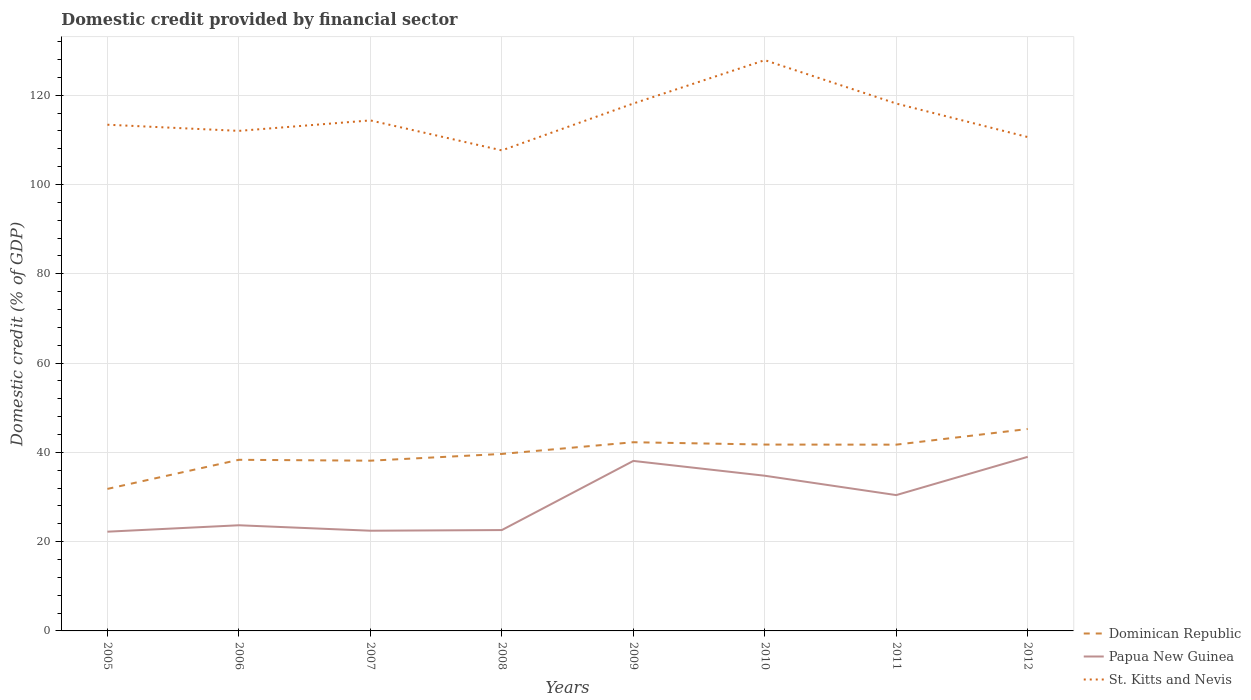How many different coloured lines are there?
Give a very brief answer. 3. Does the line corresponding to Dominican Republic intersect with the line corresponding to Papua New Guinea?
Your response must be concise. No. Across all years, what is the maximum domestic credit in St. Kitts and Nevis?
Provide a succinct answer. 107.64. What is the total domestic credit in St. Kitts and Nevis in the graph?
Keep it short and to the point. 1.39. What is the difference between the highest and the second highest domestic credit in St. Kitts and Nevis?
Your response must be concise. 20.21. What is the difference between the highest and the lowest domestic credit in Papua New Guinea?
Your answer should be very brief. 4. Is the domestic credit in St. Kitts and Nevis strictly greater than the domestic credit in Dominican Republic over the years?
Keep it short and to the point. No. What is the difference between two consecutive major ticks on the Y-axis?
Offer a terse response. 20. Are the values on the major ticks of Y-axis written in scientific E-notation?
Offer a terse response. No. Does the graph contain any zero values?
Give a very brief answer. No. Does the graph contain grids?
Provide a short and direct response. Yes. Where does the legend appear in the graph?
Give a very brief answer. Bottom right. What is the title of the graph?
Offer a terse response. Domestic credit provided by financial sector. What is the label or title of the Y-axis?
Give a very brief answer. Domestic credit (% of GDP). What is the Domestic credit (% of GDP) in Dominican Republic in 2005?
Your response must be concise. 31.81. What is the Domestic credit (% of GDP) of Papua New Guinea in 2005?
Ensure brevity in your answer.  22.23. What is the Domestic credit (% of GDP) of St. Kitts and Nevis in 2005?
Offer a very short reply. 113.39. What is the Domestic credit (% of GDP) of Dominican Republic in 2006?
Provide a succinct answer. 38.33. What is the Domestic credit (% of GDP) of Papua New Guinea in 2006?
Give a very brief answer. 23.67. What is the Domestic credit (% of GDP) in St. Kitts and Nevis in 2006?
Make the answer very short. 112.01. What is the Domestic credit (% of GDP) of Dominican Republic in 2007?
Make the answer very short. 38.13. What is the Domestic credit (% of GDP) in Papua New Guinea in 2007?
Make the answer very short. 22.45. What is the Domestic credit (% of GDP) in St. Kitts and Nevis in 2007?
Your answer should be very brief. 114.36. What is the Domestic credit (% of GDP) of Dominican Republic in 2008?
Offer a very short reply. 39.64. What is the Domestic credit (% of GDP) of Papua New Guinea in 2008?
Offer a very short reply. 22.59. What is the Domestic credit (% of GDP) in St. Kitts and Nevis in 2008?
Keep it short and to the point. 107.64. What is the Domestic credit (% of GDP) of Dominican Republic in 2009?
Provide a succinct answer. 42.27. What is the Domestic credit (% of GDP) in Papua New Guinea in 2009?
Your answer should be compact. 38.08. What is the Domestic credit (% of GDP) of St. Kitts and Nevis in 2009?
Ensure brevity in your answer.  118.14. What is the Domestic credit (% of GDP) of Dominican Republic in 2010?
Ensure brevity in your answer.  41.74. What is the Domestic credit (% of GDP) of Papua New Guinea in 2010?
Your answer should be compact. 34.76. What is the Domestic credit (% of GDP) in St. Kitts and Nevis in 2010?
Your answer should be very brief. 127.85. What is the Domestic credit (% of GDP) in Dominican Republic in 2011?
Your response must be concise. 41.72. What is the Domestic credit (% of GDP) of Papua New Guinea in 2011?
Make the answer very short. 30.43. What is the Domestic credit (% of GDP) of St. Kitts and Nevis in 2011?
Keep it short and to the point. 118.13. What is the Domestic credit (% of GDP) of Dominican Republic in 2012?
Offer a terse response. 45.23. What is the Domestic credit (% of GDP) in Papua New Guinea in 2012?
Provide a short and direct response. 38.99. What is the Domestic credit (% of GDP) of St. Kitts and Nevis in 2012?
Ensure brevity in your answer.  110.62. Across all years, what is the maximum Domestic credit (% of GDP) of Dominican Republic?
Offer a terse response. 45.23. Across all years, what is the maximum Domestic credit (% of GDP) of Papua New Guinea?
Offer a terse response. 38.99. Across all years, what is the maximum Domestic credit (% of GDP) in St. Kitts and Nevis?
Provide a short and direct response. 127.85. Across all years, what is the minimum Domestic credit (% of GDP) of Dominican Republic?
Keep it short and to the point. 31.81. Across all years, what is the minimum Domestic credit (% of GDP) in Papua New Guinea?
Make the answer very short. 22.23. Across all years, what is the minimum Domestic credit (% of GDP) in St. Kitts and Nevis?
Offer a very short reply. 107.64. What is the total Domestic credit (% of GDP) in Dominican Republic in the graph?
Offer a terse response. 318.89. What is the total Domestic credit (% of GDP) in Papua New Guinea in the graph?
Provide a succinct answer. 233.19. What is the total Domestic credit (% of GDP) in St. Kitts and Nevis in the graph?
Ensure brevity in your answer.  922.14. What is the difference between the Domestic credit (% of GDP) in Dominican Republic in 2005 and that in 2006?
Your answer should be very brief. -6.52. What is the difference between the Domestic credit (% of GDP) in Papua New Guinea in 2005 and that in 2006?
Keep it short and to the point. -1.44. What is the difference between the Domestic credit (% of GDP) of St. Kitts and Nevis in 2005 and that in 2006?
Your response must be concise. 1.38. What is the difference between the Domestic credit (% of GDP) of Dominican Republic in 2005 and that in 2007?
Make the answer very short. -6.32. What is the difference between the Domestic credit (% of GDP) in Papua New Guinea in 2005 and that in 2007?
Ensure brevity in your answer.  -0.22. What is the difference between the Domestic credit (% of GDP) in St. Kitts and Nevis in 2005 and that in 2007?
Give a very brief answer. -0.96. What is the difference between the Domestic credit (% of GDP) of Dominican Republic in 2005 and that in 2008?
Keep it short and to the point. -7.83. What is the difference between the Domestic credit (% of GDP) of Papua New Guinea in 2005 and that in 2008?
Make the answer very short. -0.36. What is the difference between the Domestic credit (% of GDP) in St. Kitts and Nevis in 2005 and that in 2008?
Keep it short and to the point. 5.75. What is the difference between the Domestic credit (% of GDP) in Dominican Republic in 2005 and that in 2009?
Ensure brevity in your answer.  -10.45. What is the difference between the Domestic credit (% of GDP) of Papua New Guinea in 2005 and that in 2009?
Provide a short and direct response. -15.85. What is the difference between the Domestic credit (% of GDP) of St. Kitts and Nevis in 2005 and that in 2009?
Your answer should be very brief. -4.75. What is the difference between the Domestic credit (% of GDP) of Dominican Republic in 2005 and that in 2010?
Provide a short and direct response. -9.93. What is the difference between the Domestic credit (% of GDP) in Papua New Guinea in 2005 and that in 2010?
Keep it short and to the point. -12.53. What is the difference between the Domestic credit (% of GDP) in St. Kitts and Nevis in 2005 and that in 2010?
Provide a succinct answer. -14.46. What is the difference between the Domestic credit (% of GDP) of Dominican Republic in 2005 and that in 2011?
Offer a very short reply. -9.91. What is the difference between the Domestic credit (% of GDP) of Papua New Guinea in 2005 and that in 2011?
Offer a very short reply. -8.2. What is the difference between the Domestic credit (% of GDP) of St. Kitts and Nevis in 2005 and that in 2011?
Provide a short and direct response. -4.74. What is the difference between the Domestic credit (% of GDP) of Dominican Republic in 2005 and that in 2012?
Provide a short and direct response. -13.42. What is the difference between the Domestic credit (% of GDP) of Papua New Guinea in 2005 and that in 2012?
Your answer should be very brief. -16.77. What is the difference between the Domestic credit (% of GDP) in St. Kitts and Nevis in 2005 and that in 2012?
Keep it short and to the point. 2.77. What is the difference between the Domestic credit (% of GDP) of Dominican Republic in 2006 and that in 2007?
Make the answer very short. 0.2. What is the difference between the Domestic credit (% of GDP) of Papua New Guinea in 2006 and that in 2007?
Your answer should be very brief. 1.22. What is the difference between the Domestic credit (% of GDP) in St. Kitts and Nevis in 2006 and that in 2007?
Your answer should be very brief. -2.34. What is the difference between the Domestic credit (% of GDP) of Dominican Republic in 2006 and that in 2008?
Give a very brief answer. -1.31. What is the difference between the Domestic credit (% of GDP) of Papua New Guinea in 2006 and that in 2008?
Provide a succinct answer. 1.07. What is the difference between the Domestic credit (% of GDP) in St. Kitts and Nevis in 2006 and that in 2008?
Offer a very short reply. 4.37. What is the difference between the Domestic credit (% of GDP) in Dominican Republic in 2006 and that in 2009?
Your answer should be compact. -3.93. What is the difference between the Domestic credit (% of GDP) of Papua New Guinea in 2006 and that in 2009?
Provide a succinct answer. -14.41. What is the difference between the Domestic credit (% of GDP) in St. Kitts and Nevis in 2006 and that in 2009?
Give a very brief answer. -6.13. What is the difference between the Domestic credit (% of GDP) in Dominican Republic in 2006 and that in 2010?
Provide a succinct answer. -3.41. What is the difference between the Domestic credit (% of GDP) of Papua New Guinea in 2006 and that in 2010?
Your answer should be compact. -11.1. What is the difference between the Domestic credit (% of GDP) in St. Kitts and Nevis in 2006 and that in 2010?
Ensure brevity in your answer.  -15.84. What is the difference between the Domestic credit (% of GDP) in Dominican Republic in 2006 and that in 2011?
Your answer should be very brief. -3.39. What is the difference between the Domestic credit (% of GDP) in Papua New Guinea in 2006 and that in 2011?
Give a very brief answer. -6.76. What is the difference between the Domestic credit (% of GDP) in St. Kitts and Nevis in 2006 and that in 2011?
Keep it short and to the point. -6.12. What is the difference between the Domestic credit (% of GDP) of Dominican Republic in 2006 and that in 2012?
Your response must be concise. -6.9. What is the difference between the Domestic credit (% of GDP) in Papua New Guinea in 2006 and that in 2012?
Your answer should be compact. -15.33. What is the difference between the Domestic credit (% of GDP) in St. Kitts and Nevis in 2006 and that in 2012?
Provide a succinct answer. 1.39. What is the difference between the Domestic credit (% of GDP) in Dominican Republic in 2007 and that in 2008?
Make the answer very short. -1.51. What is the difference between the Domestic credit (% of GDP) of Papua New Guinea in 2007 and that in 2008?
Ensure brevity in your answer.  -0.15. What is the difference between the Domestic credit (% of GDP) in St. Kitts and Nevis in 2007 and that in 2008?
Offer a terse response. 6.72. What is the difference between the Domestic credit (% of GDP) in Dominican Republic in 2007 and that in 2009?
Your answer should be very brief. -4.13. What is the difference between the Domestic credit (% of GDP) of Papua New Guinea in 2007 and that in 2009?
Keep it short and to the point. -15.63. What is the difference between the Domestic credit (% of GDP) in St. Kitts and Nevis in 2007 and that in 2009?
Your response must be concise. -3.78. What is the difference between the Domestic credit (% of GDP) of Dominican Republic in 2007 and that in 2010?
Ensure brevity in your answer.  -3.61. What is the difference between the Domestic credit (% of GDP) of Papua New Guinea in 2007 and that in 2010?
Your response must be concise. -12.32. What is the difference between the Domestic credit (% of GDP) in St. Kitts and Nevis in 2007 and that in 2010?
Offer a very short reply. -13.5. What is the difference between the Domestic credit (% of GDP) in Dominican Republic in 2007 and that in 2011?
Make the answer very short. -3.59. What is the difference between the Domestic credit (% of GDP) in Papua New Guinea in 2007 and that in 2011?
Offer a terse response. -7.98. What is the difference between the Domestic credit (% of GDP) in St. Kitts and Nevis in 2007 and that in 2011?
Offer a very short reply. -3.78. What is the difference between the Domestic credit (% of GDP) of Dominican Republic in 2007 and that in 2012?
Give a very brief answer. -7.1. What is the difference between the Domestic credit (% of GDP) of Papua New Guinea in 2007 and that in 2012?
Keep it short and to the point. -16.55. What is the difference between the Domestic credit (% of GDP) of St. Kitts and Nevis in 2007 and that in 2012?
Ensure brevity in your answer.  3.73. What is the difference between the Domestic credit (% of GDP) in Dominican Republic in 2008 and that in 2009?
Give a very brief answer. -2.62. What is the difference between the Domestic credit (% of GDP) in Papua New Guinea in 2008 and that in 2009?
Your answer should be compact. -15.49. What is the difference between the Domestic credit (% of GDP) in St. Kitts and Nevis in 2008 and that in 2009?
Make the answer very short. -10.5. What is the difference between the Domestic credit (% of GDP) in Dominican Republic in 2008 and that in 2010?
Your response must be concise. -2.1. What is the difference between the Domestic credit (% of GDP) in Papua New Guinea in 2008 and that in 2010?
Offer a very short reply. -12.17. What is the difference between the Domestic credit (% of GDP) in St. Kitts and Nevis in 2008 and that in 2010?
Your answer should be compact. -20.21. What is the difference between the Domestic credit (% of GDP) of Dominican Republic in 2008 and that in 2011?
Make the answer very short. -2.08. What is the difference between the Domestic credit (% of GDP) of Papua New Guinea in 2008 and that in 2011?
Provide a short and direct response. -7.83. What is the difference between the Domestic credit (% of GDP) of St. Kitts and Nevis in 2008 and that in 2011?
Provide a succinct answer. -10.5. What is the difference between the Domestic credit (% of GDP) of Dominican Republic in 2008 and that in 2012?
Make the answer very short. -5.59. What is the difference between the Domestic credit (% of GDP) in Papua New Guinea in 2008 and that in 2012?
Make the answer very short. -16.4. What is the difference between the Domestic credit (% of GDP) in St. Kitts and Nevis in 2008 and that in 2012?
Offer a very short reply. -2.99. What is the difference between the Domestic credit (% of GDP) of Dominican Republic in 2009 and that in 2010?
Your response must be concise. 0.52. What is the difference between the Domestic credit (% of GDP) of Papua New Guinea in 2009 and that in 2010?
Offer a terse response. 3.31. What is the difference between the Domestic credit (% of GDP) in St. Kitts and Nevis in 2009 and that in 2010?
Keep it short and to the point. -9.72. What is the difference between the Domestic credit (% of GDP) in Dominican Republic in 2009 and that in 2011?
Keep it short and to the point. 0.54. What is the difference between the Domestic credit (% of GDP) in Papua New Guinea in 2009 and that in 2011?
Offer a terse response. 7.65. What is the difference between the Domestic credit (% of GDP) in St. Kitts and Nevis in 2009 and that in 2011?
Your answer should be very brief. 0. What is the difference between the Domestic credit (% of GDP) of Dominican Republic in 2009 and that in 2012?
Your answer should be very brief. -2.97. What is the difference between the Domestic credit (% of GDP) in Papua New Guinea in 2009 and that in 2012?
Your answer should be very brief. -0.92. What is the difference between the Domestic credit (% of GDP) in St. Kitts and Nevis in 2009 and that in 2012?
Provide a short and direct response. 7.51. What is the difference between the Domestic credit (% of GDP) in Papua New Guinea in 2010 and that in 2011?
Your answer should be compact. 4.34. What is the difference between the Domestic credit (% of GDP) of St. Kitts and Nevis in 2010 and that in 2011?
Provide a short and direct response. 9.72. What is the difference between the Domestic credit (% of GDP) in Dominican Republic in 2010 and that in 2012?
Your response must be concise. -3.49. What is the difference between the Domestic credit (% of GDP) of Papua New Guinea in 2010 and that in 2012?
Offer a very short reply. -4.23. What is the difference between the Domestic credit (% of GDP) in St. Kitts and Nevis in 2010 and that in 2012?
Offer a terse response. 17.23. What is the difference between the Domestic credit (% of GDP) in Dominican Republic in 2011 and that in 2012?
Ensure brevity in your answer.  -3.51. What is the difference between the Domestic credit (% of GDP) in Papua New Guinea in 2011 and that in 2012?
Offer a terse response. -8.57. What is the difference between the Domestic credit (% of GDP) of St. Kitts and Nevis in 2011 and that in 2012?
Provide a short and direct response. 7.51. What is the difference between the Domestic credit (% of GDP) in Dominican Republic in 2005 and the Domestic credit (% of GDP) in Papua New Guinea in 2006?
Make the answer very short. 8.15. What is the difference between the Domestic credit (% of GDP) of Dominican Republic in 2005 and the Domestic credit (% of GDP) of St. Kitts and Nevis in 2006?
Your response must be concise. -80.2. What is the difference between the Domestic credit (% of GDP) in Papua New Guinea in 2005 and the Domestic credit (% of GDP) in St. Kitts and Nevis in 2006?
Provide a short and direct response. -89.78. What is the difference between the Domestic credit (% of GDP) in Dominican Republic in 2005 and the Domestic credit (% of GDP) in Papua New Guinea in 2007?
Make the answer very short. 9.37. What is the difference between the Domestic credit (% of GDP) of Dominican Republic in 2005 and the Domestic credit (% of GDP) of St. Kitts and Nevis in 2007?
Your answer should be very brief. -82.54. What is the difference between the Domestic credit (% of GDP) of Papua New Guinea in 2005 and the Domestic credit (% of GDP) of St. Kitts and Nevis in 2007?
Provide a short and direct response. -92.13. What is the difference between the Domestic credit (% of GDP) of Dominican Republic in 2005 and the Domestic credit (% of GDP) of Papua New Guinea in 2008?
Give a very brief answer. 9.22. What is the difference between the Domestic credit (% of GDP) in Dominican Republic in 2005 and the Domestic credit (% of GDP) in St. Kitts and Nevis in 2008?
Keep it short and to the point. -75.82. What is the difference between the Domestic credit (% of GDP) in Papua New Guinea in 2005 and the Domestic credit (% of GDP) in St. Kitts and Nevis in 2008?
Offer a terse response. -85.41. What is the difference between the Domestic credit (% of GDP) in Dominican Republic in 2005 and the Domestic credit (% of GDP) in Papua New Guinea in 2009?
Keep it short and to the point. -6.26. What is the difference between the Domestic credit (% of GDP) in Dominican Republic in 2005 and the Domestic credit (% of GDP) in St. Kitts and Nevis in 2009?
Offer a terse response. -86.32. What is the difference between the Domestic credit (% of GDP) in Papua New Guinea in 2005 and the Domestic credit (% of GDP) in St. Kitts and Nevis in 2009?
Give a very brief answer. -95.91. What is the difference between the Domestic credit (% of GDP) of Dominican Republic in 2005 and the Domestic credit (% of GDP) of Papua New Guinea in 2010?
Keep it short and to the point. -2.95. What is the difference between the Domestic credit (% of GDP) of Dominican Republic in 2005 and the Domestic credit (% of GDP) of St. Kitts and Nevis in 2010?
Your response must be concise. -96.04. What is the difference between the Domestic credit (% of GDP) of Papua New Guinea in 2005 and the Domestic credit (% of GDP) of St. Kitts and Nevis in 2010?
Make the answer very short. -105.62. What is the difference between the Domestic credit (% of GDP) in Dominican Republic in 2005 and the Domestic credit (% of GDP) in Papua New Guinea in 2011?
Offer a terse response. 1.39. What is the difference between the Domestic credit (% of GDP) of Dominican Republic in 2005 and the Domestic credit (% of GDP) of St. Kitts and Nevis in 2011?
Offer a terse response. -86.32. What is the difference between the Domestic credit (% of GDP) in Papua New Guinea in 2005 and the Domestic credit (% of GDP) in St. Kitts and Nevis in 2011?
Provide a succinct answer. -95.91. What is the difference between the Domestic credit (% of GDP) of Dominican Republic in 2005 and the Domestic credit (% of GDP) of Papua New Guinea in 2012?
Your answer should be very brief. -7.18. What is the difference between the Domestic credit (% of GDP) of Dominican Republic in 2005 and the Domestic credit (% of GDP) of St. Kitts and Nevis in 2012?
Your answer should be compact. -78.81. What is the difference between the Domestic credit (% of GDP) in Papua New Guinea in 2005 and the Domestic credit (% of GDP) in St. Kitts and Nevis in 2012?
Your response must be concise. -88.4. What is the difference between the Domestic credit (% of GDP) in Dominican Republic in 2006 and the Domestic credit (% of GDP) in Papua New Guinea in 2007?
Your answer should be very brief. 15.89. What is the difference between the Domestic credit (% of GDP) of Dominican Republic in 2006 and the Domestic credit (% of GDP) of St. Kitts and Nevis in 2007?
Offer a terse response. -76.02. What is the difference between the Domestic credit (% of GDP) of Papua New Guinea in 2006 and the Domestic credit (% of GDP) of St. Kitts and Nevis in 2007?
Keep it short and to the point. -90.69. What is the difference between the Domestic credit (% of GDP) in Dominican Republic in 2006 and the Domestic credit (% of GDP) in Papua New Guinea in 2008?
Keep it short and to the point. 15.74. What is the difference between the Domestic credit (% of GDP) in Dominican Republic in 2006 and the Domestic credit (% of GDP) in St. Kitts and Nevis in 2008?
Keep it short and to the point. -69.31. What is the difference between the Domestic credit (% of GDP) in Papua New Guinea in 2006 and the Domestic credit (% of GDP) in St. Kitts and Nevis in 2008?
Your response must be concise. -83.97. What is the difference between the Domestic credit (% of GDP) in Dominican Republic in 2006 and the Domestic credit (% of GDP) in Papua New Guinea in 2009?
Provide a short and direct response. 0.25. What is the difference between the Domestic credit (% of GDP) of Dominican Republic in 2006 and the Domestic credit (% of GDP) of St. Kitts and Nevis in 2009?
Ensure brevity in your answer.  -79.8. What is the difference between the Domestic credit (% of GDP) in Papua New Guinea in 2006 and the Domestic credit (% of GDP) in St. Kitts and Nevis in 2009?
Make the answer very short. -94.47. What is the difference between the Domestic credit (% of GDP) of Dominican Republic in 2006 and the Domestic credit (% of GDP) of Papua New Guinea in 2010?
Provide a short and direct response. 3.57. What is the difference between the Domestic credit (% of GDP) in Dominican Republic in 2006 and the Domestic credit (% of GDP) in St. Kitts and Nevis in 2010?
Ensure brevity in your answer.  -89.52. What is the difference between the Domestic credit (% of GDP) in Papua New Guinea in 2006 and the Domestic credit (% of GDP) in St. Kitts and Nevis in 2010?
Keep it short and to the point. -104.19. What is the difference between the Domestic credit (% of GDP) of Dominican Republic in 2006 and the Domestic credit (% of GDP) of Papua New Guinea in 2011?
Offer a very short reply. 7.91. What is the difference between the Domestic credit (% of GDP) of Dominican Republic in 2006 and the Domestic credit (% of GDP) of St. Kitts and Nevis in 2011?
Make the answer very short. -79.8. What is the difference between the Domestic credit (% of GDP) in Papua New Guinea in 2006 and the Domestic credit (% of GDP) in St. Kitts and Nevis in 2011?
Your answer should be compact. -94.47. What is the difference between the Domestic credit (% of GDP) of Dominican Republic in 2006 and the Domestic credit (% of GDP) of Papua New Guinea in 2012?
Give a very brief answer. -0.66. What is the difference between the Domestic credit (% of GDP) of Dominican Republic in 2006 and the Domestic credit (% of GDP) of St. Kitts and Nevis in 2012?
Provide a succinct answer. -72.29. What is the difference between the Domestic credit (% of GDP) in Papua New Guinea in 2006 and the Domestic credit (% of GDP) in St. Kitts and Nevis in 2012?
Your response must be concise. -86.96. What is the difference between the Domestic credit (% of GDP) of Dominican Republic in 2007 and the Domestic credit (% of GDP) of Papua New Guinea in 2008?
Your answer should be compact. 15.54. What is the difference between the Domestic credit (% of GDP) of Dominican Republic in 2007 and the Domestic credit (% of GDP) of St. Kitts and Nevis in 2008?
Provide a succinct answer. -69.51. What is the difference between the Domestic credit (% of GDP) in Papua New Guinea in 2007 and the Domestic credit (% of GDP) in St. Kitts and Nevis in 2008?
Keep it short and to the point. -85.19. What is the difference between the Domestic credit (% of GDP) of Dominican Republic in 2007 and the Domestic credit (% of GDP) of Papua New Guinea in 2009?
Make the answer very short. 0.06. What is the difference between the Domestic credit (% of GDP) of Dominican Republic in 2007 and the Domestic credit (% of GDP) of St. Kitts and Nevis in 2009?
Your response must be concise. -80. What is the difference between the Domestic credit (% of GDP) in Papua New Guinea in 2007 and the Domestic credit (% of GDP) in St. Kitts and Nevis in 2009?
Give a very brief answer. -95.69. What is the difference between the Domestic credit (% of GDP) of Dominican Republic in 2007 and the Domestic credit (% of GDP) of Papua New Guinea in 2010?
Give a very brief answer. 3.37. What is the difference between the Domestic credit (% of GDP) in Dominican Republic in 2007 and the Domestic credit (% of GDP) in St. Kitts and Nevis in 2010?
Offer a terse response. -89.72. What is the difference between the Domestic credit (% of GDP) in Papua New Guinea in 2007 and the Domestic credit (% of GDP) in St. Kitts and Nevis in 2010?
Keep it short and to the point. -105.41. What is the difference between the Domestic credit (% of GDP) in Dominican Republic in 2007 and the Domestic credit (% of GDP) in Papua New Guinea in 2011?
Your response must be concise. 7.71. What is the difference between the Domestic credit (% of GDP) of Dominican Republic in 2007 and the Domestic credit (% of GDP) of St. Kitts and Nevis in 2011?
Your answer should be compact. -80. What is the difference between the Domestic credit (% of GDP) in Papua New Guinea in 2007 and the Domestic credit (% of GDP) in St. Kitts and Nevis in 2011?
Give a very brief answer. -95.69. What is the difference between the Domestic credit (% of GDP) in Dominican Republic in 2007 and the Domestic credit (% of GDP) in Papua New Guinea in 2012?
Your response must be concise. -0.86. What is the difference between the Domestic credit (% of GDP) of Dominican Republic in 2007 and the Domestic credit (% of GDP) of St. Kitts and Nevis in 2012?
Provide a succinct answer. -72.49. What is the difference between the Domestic credit (% of GDP) in Papua New Guinea in 2007 and the Domestic credit (% of GDP) in St. Kitts and Nevis in 2012?
Keep it short and to the point. -88.18. What is the difference between the Domestic credit (% of GDP) in Dominican Republic in 2008 and the Domestic credit (% of GDP) in Papua New Guinea in 2009?
Keep it short and to the point. 1.57. What is the difference between the Domestic credit (% of GDP) of Dominican Republic in 2008 and the Domestic credit (% of GDP) of St. Kitts and Nevis in 2009?
Your answer should be compact. -78.49. What is the difference between the Domestic credit (% of GDP) of Papua New Guinea in 2008 and the Domestic credit (% of GDP) of St. Kitts and Nevis in 2009?
Make the answer very short. -95.54. What is the difference between the Domestic credit (% of GDP) in Dominican Republic in 2008 and the Domestic credit (% of GDP) in Papua New Guinea in 2010?
Provide a short and direct response. 4.88. What is the difference between the Domestic credit (% of GDP) in Dominican Republic in 2008 and the Domestic credit (% of GDP) in St. Kitts and Nevis in 2010?
Make the answer very short. -88.21. What is the difference between the Domestic credit (% of GDP) of Papua New Guinea in 2008 and the Domestic credit (% of GDP) of St. Kitts and Nevis in 2010?
Your response must be concise. -105.26. What is the difference between the Domestic credit (% of GDP) in Dominican Republic in 2008 and the Domestic credit (% of GDP) in Papua New Guinea in 2011?
Provide a short and direct response. 9.22. What is the difference between the Domestic credit (% of GDP) in Dominican Republic in 2008 and the Domestic credit (% of GDP) in St. Kitts and Nevis in 2011?
Ensure brevity in your answer.  -78.49. What is the difference between the Domestic credit (% of GDP) of Papua New Guinea in 2008 and the Domestic credit (% of GDP) of St. Kitts and Nevis in 2011?
Offer a terse response. -95.54. What is the difference between the Domestic credit (% of GDP) in Dominican Republic in 2008 and the Domestic credit (% of GDP) in Papua New Guinea in 2012?
Your answer should be very brief. 0.65. What is the difference between the Domestic credit (% of GDP) in Dominican Republic in 2008 and the Domestic credit (% of GDP) in St. Kitts and Nevis in 2012?
Provide a short and direct response. -70.98. What is the difference between the Domestic credit (% of GDP) of Papua New Guinea in 2008 and the Domestic credit (% of GDP) of St. Kitts and Nevis in 2012?
Your answer should be very brief. -88.03. What is the difference between the Domestic credit (% of GDP) of Dominican Republic in 2009 and the Domestic credit (% of GDP) of Papua New Guinea in 2010?
Ensure brevity in your answer.  7.5. What is the difference between the Domestic credit (% of GDP) of Dominican Republic in 2009 and the Domestic credit (% of GDP) of St. Kitts and Nevis in 2010?
Your answer should be compact. -85.59. What is the difference between the Domestic credit (% of GDP) of Papua New Guinea in 2009 and the Domestic credit (% of GDP) of St. Kitts and Nevis in 2010?
Provide a succinct answer. -89.78. What is the difference between the Domestic credit (% of GDP) of Dominican Republic in 2009 and the Domestic credit (% of GDP) of Papua New Guinea in 2011?
Offer a very short reply. 11.84. What is the difference between the Domestic credit (% of GDP) of Dominican Republic in 2009 and the Domestic credit (% of GDP) of St. Kitts and Nevis in 2011?
Give a very brief answer. -75.87. What is the difference between the Domestic credit (% of GDP) in Papua New Guinea in 2009 and the Domestic credit (% of GDP) in St. Kitts and Nevis in 2011?
Your answer should be compact. -80.06. What is the difference between the Domestic credit (% of GDP) of Dominican Republic in 2009 and the Domestic credit (% of GDP) of Papua New Guinea in 2012?
Offer a very short reply. 3.27. What is the difference between the Domestic credit (% of GDP) of Dominican Republic in 2009 and the Domestic credit (% of GDP) of St. Kitts and Nevis in 2012?
Offer a very short reply. -68.36. What is the difference between the Domestic credit (% of GDP) of Papua New Guinea in 2009 and the Domestic credit (% of GDP) of St. Kitts and Nevis in 2012?
Your answer should be compact. -72.55. What is the difference between the Domestic credit (% of GDP) in Dominican Republic in 2010 and the Domestic credit (% of GDP) in Papua New Guinea in 2011?
Offer a terse response. 11.32. What is the difference between the Domestic credit (% of GDP) of Dominican Republic in 2010 and the Domestic credit (% of GDP) of St. Kitts and Nevis in 2011?
Offer a very short reply. -76.39. What is the difference between the Domestic credit (% of GDP) in Papua New Guinea in 2010 and the Domestic credit (% of GDP) in St. Kitts and Nevis in 2011?
Make the answer very short. -83.37. What is the difference between the Domestic credit (% of GDP) in Dominican Republic in 2010 and the Domestic credit (% of GDP) in Papua New Guinea in 2012?
Your response must be concise. 2.75. What is the difference between the Domestic credit (% of GDP) in Dominican Republic in 2010 and the Domestic credit (% of GDP) in St. Kitts and Nevis in 2012?
Keep it short and to the point. -68.88. What is the difference between the Domestic credit (% of GDP) of Papua New Guinea in 2010 and the Domestic credit (% of GDP) of St. Kitts and Nevis in 2012?
Your answer should be very brief. -75.86. What is the difference between the Domestic credit (% of GDP) in Dominican Republic in 2011 and the Domestic credit (% of GDP) in Papua New Guinea in 2012?
Give a very brief answer. 2.73. What is the difference between the Domestic credit (% of GDP) of Dominican Republic in 2011 and the Domestic credit (% of GDP) of St. Kitts and Nevis in 2012?
Ensure brevity in your answer.  -68.9. What is the difference between the Domestic credit (% of GDP) of Papua New Guinea in 2011 and the Domestic credit (% of GDP) of St. Kitts and Nevis in 2012?
Give a very brief answer. -80.2. What is the average Domestic credit (% of GDP) of Dominican Republic per year?
Ensure brevity in your answer.  39.86. What is the average Domestic credit (% of GDP) in Papua New Guinea per year?
Provide a succinct answer. 29.15. What is the average Domestic credit (% of GDP) of St. Kitts and Nevis per year?
Provide a short and direct response. 115.27. In the year 2005, what is the difference between the Domestic credit (% of GDP) in Dominican Republic and Domestic credit (% of GDP) in Papua New Guinea?
Ensure brevity in your answer.  9.59. In the year 2005, what is the difference between the Domestic credit (% of GDP) in Dominican Republic and Domestic credit (% of GDP) in St. Kitts and Nevis?
Make the answer very short. -81.58. In the year 2005, what is the difference between the Domestic credit (% of GDP) in Papua New Guinea and Domestic credit (% of GDP) in St. Kitts and Nevis?
Offer a terse response. -91.16. In the year 2006, what is the difference between the Domestic credit (% of GDP) of Dominican Republic and Domestic credit (% of GDP) of Papua New Guinea?
Your answer should be compact. 14.67. In the year 2006, what is the difference between the Domestic credit (% of GDP) of Dominican Republic and Domestic credit (% of GDP) of St. Kitts and Nevis?
Make the answer very short. -73.68. In the year 2006, what is the difference between the Domestic credit (% of GDP) of Papua New Guinea and Domestic credit (% of GDP) of St. Kitts and Nevis?
Your answer should be compact. -88.34. In the year 2007, what is the difference between the Domestic credit (% of GDP) of Dominican Republic and Domestic credit (% of GDP) of Papua New Guinea?
Offer a very short reply. 15.69. In the year 2007, what is the difference between the Domestic credit (% of GDP) of Dominican Republic and Domestic credit (% of GDP) of St. Kitts and Nevis?
Your answer should be compact. -76.22. In the year 2007, what is the difference between the Domestic credit (% of GDP) in Papua New Guinea and Domestic credit (% of GDP) in St. Kitts and Nevis?
Your answer should be compact. -91.91. In the year 2008, what is the difference between the Domestic credit (% of GDP) of Dominican Republic and Domestic credit (% of GDP) of Papua New Guinea?
Keep it short and to the point. 17.05. In the year 2008, what is the difference between the Domestic credit (% of GDP) of Dominican Republic and Domestic credit (% of GDP) of St. Kitts and Nevis?
Keep it short and to the point. -67.99. In the year 2008, what is the difference between the Domestic credit (% of GDP) of Papua New Guinea and Domestic credit (% of GDP) of St. Kitts and Nevis?
Ensure brevity in your answer.  -85.05. In the year 2009, what is the difference between the Domestic credit (% of GDP) of Dominican Republic and Domestic credit (% of GDP) of Papua New Guinea?
Offer a very short reply. 4.19. In the year 2009, what is the difference between the Domestic credit (% of GDP) in Dominican Republic and Domestic credit (% of GDP) in St. Kitts and Nevis?
Make the answer very short. -75.87. In the year 2009, what is the difference between the Domestic credit (% of GDP) of Papua New Guinea and Domestic credit (% of GDP) of St. Kitts and Nevis?
Your response must be concise. -80.06. In the year 2010, what is the difference between the Domestic credit (% of GDP) in Dominican Republic and Domestic credit (% of GDP) in Papua New Guinea?
Provide a succinct answer. 6.98. In the year 2010, what is the difference between the Domestic credit (% of GDP) of Dominican Republic and Domestic credit (% of GDP) of St. Kitts and Nevis?
Keep it short and to the point. -86.11. In the year 2010, what is the difference between the Domestic credit (% of GDP) in Papua New Guinea and Domestic credit (% of GDP) in St. Kitts and Nevis?
Offer a terse response. -93.09. In the year 2011, what is the difference between the Domestic credit (% of GDP) in Dominican Republic and Domestic credit (% of GDP) in Papua New Guinea?
Your answer should be compact. 11.3. In the year 2011, what is the difference between the Domestic credit (% of GDP) of Dominican Republic and Domestic credit (% of GDP) of St. Kitts and Nevis?
Offer a very short reply. -76.41. In the year 2011, what is the difference between the Domestic credit (% of GDP) in Papua New Guinea and Domestic credit (% of GDP) in St. Kitts and Nevis?
Your answer should be compact. -87.71. In the year 2012, what is the difference between the Domestic credit (% of GDP) of Dominican Republic and Domestic credit (% of GDP) of Papua New Guinea?
Provide a succinct answer. 6.24. In the year 2012, what is the difference between the Domestic credit (% of GDP) of Dominican Republic and Domestic credit (% of GDP) of St. Kitts and Nevis?
Your response must be concise. -65.39. In the year 2012, what is the difference between the Domestic credit (% of GDP) of Papua New Guinea and Domestic credit (% of GDP) of St. Kitts and Nevis?
Give a very brief answer. -71.63. What is the ratio of the Domestic credit (% of GDP) in Dominican Republic in 2005 to that in 2006?
Make the answer very short. 0.83. What is the ratio of the Domestic credit (% of GDP) in Papua New Guinea in 2005 to that in 2006?
Offer a terse response. 0.94. What is the ratio of the Domestic credit (% of GDP) in St. Kitts and Nevis in 2005 to that in 2006?
Provide a succinct answer. 1.01. What is the ratio of the Domestic credit (% of GDP) in Dominican Republic in 2005 to that in 2007?
Provide a succinct answer. 0.83. What is the ratio of the Domestic credit (% of GDP) in Papua New Guinea in 2005 to that in 2007?
Offer a very short reply. 0.99. What is the ratio of the Domestic credit (% of GDP) in St. Kitts and Nevis in 2005 to that in 2007?
Give a very brief answer. 0.99. What is the ratio of the Domestic credit (% of GDP) in Dominican Republic in 2005 to that in 2008?
Your answer should be very brief. 0.8. What is the ratio of the Domestic credit (% of GDP) of Papua New Guinea in 2005 to that in 2008?
Offer a terse response. 0.98. What is the ratio of the Domestic credit (% of GDP) of St. Kitts and Nevis in 2005 to that in 2008?
Give a very brief answer. 1.05. What is the ratio of the Domestic credit (% of GDP) in Dominican Republic in 2005 to that in 2009?
Your answer should be compact. 0.75. What is the ratio of the Domestic credit (% of GDP) of Papua New Guinea in 2005 to that in 2009?
Ensure brevity in your answer.  0.58. What is the ratio of the Domestic credit (% of GDP) in St. Kitts and Nevis in 2005 to that in 2009?
Offer a very short reply. 0.96. What is the ratio of the Domestic credit (% of GDP) of Dominican Republic in 2005 to that in 2010?
Ensure brevity in your answer.  0.76. What is the ratio of the Domestic credit (% of GDP) in Papua New Guinea in 2005 to that in 2010?
Offer a terse response. 0.64. What is the ratio of the Domestic credit (% of GDP) in St. Kitts and Nevis in 2005 to that in 2010?
Make the answer very short. 0.89. What is the ratio of the Domestic credit (% of GDP) of Dominican Republic in 2005 to that in 2011?
Your answer should be compact. 0.76. What is the ratio of the Domestic credit (% of GDP) in Papua New Guinea in 2005 to that in 2011?
Your response must be concise. 0.73. What is the ratio of the Domestic credit (% of GDP) in St. Kitts and Nevis in 2005 to that in 2011?
Provide a short and direct response. 0.96. What is the ratio of the Domestic credit (% of GDP) in Dominican Republic in 2005 to that in 2012?
Keep it short and to the point. 0.7. What is the ratio of the Domestic credit (% of GDP) in Papua New Guinea in 2005 to that in 2012?
Your response must be concise. 0.57. What is the ratio of the Domestic credit (% of GDP) of St. Kitts and Nevis in 2005 to that in 2012?
Make the answer very short. 1.02. What is the ratio of the Domestic credit (% of GDP) of Dominican Republic in 2006 to that in 2007?
Provide a succinct answer. 1.01. What is the ratio of the Domestic credit (% of GDP) in Papua New Guinea in 2006 to that in 2007?
Make the answer very short. 1.05. What is the ratio of the Domestic credit (% of GDP) in St. Kitts and Nevis in 2006 to that in 2007?
Offer a terse response. 0.98. What is the ratio of the Domestic credit (% of GDP) of Dominican Republic in 2006 to that in 2008?
Ensure brevity in your answer.  0.97. What is the ratio of the Domestic credit (% of GDP) of Papua New Guinea in 2006 to that in 2008?
Provide a short and direct response. 1.05. What is the ratio of the Domestic credit (% of GDP) in St. Kitts and Nevis in 2006 to that in 2008?
Offer a terse response. 1.04. What is the ratio of the Domestic credit (% of GDP) of Dominican Republic in 2006 to that in 2009?
Offer a very short reply. 0.91. What is the ratio of the Domestic credit (% of GDP) of Papua New Guinea in 2006 to that in 2009?
Your answer should be compact. 0.62. What is the ratio of the Domestic credit (% of GDP) in St. Kitts and Nevis in 2006 to that in 2009?
Offer a terse response. 0.95. What is the ratio of the Domestic credit (% of GDP) of Dominican Republic in 2006 to that in 2010?
Your answer should be compact. 0.92. What is the ratio of the Domestic credit (% of GDP) of Papua New Guinea in 2006 to that in 2010?
Provide a short and direct response. 0.68. What is the ratio of the Domestic credit (% of GDP) in St. Kitts and Nevis in 2006 to that in 2010?
Offer a very short reply. 0.88. What is the ratio of the Domestic credit (% of GDP) in Dominican Republic in 2006 to that in 2011?
Keep it short and to the point. 0.92. What is the ratio of the Domestic credit (% of GDP) in St. Kitts and Nevis in 2006 to that in 2011?
Make the answer very short. 0.95. What is the ratio of the Domestic credit (% of GDP) in Dominican Republic in 2006 to that in 2012?
Give a very brief answer. 0.85. What is the ratio of the Domestic credit (% of GDP) of Papua New Guinea in 2006 to that in 2012?
Offer a very short reply. 0.61. What is the ratio of the Domestic credit (% of GDP) in St. Kitts and Nevis in 2006 to that in 2012?
Offer a terse response. 1.01. What is the ratio of the Domestic credit (% of GDP) in Dominican Republic in 2007 to that in 2008?
Your answer should be compact. 0.96. What is the ratio of the Domestic credit (% of GDP) of St. Kitts and Nevis in 2007 to that in 2008?
Your answer should be very brief. 1.06. What is the ratio of the Domestic credit (% of GDP) of Dominican Republic in 2007 to that in 2009?
Provide a short and direct response. 0.9. What is the ratio of the Domestic credit (% of GDP) in Papua New Guinea in 2007 to that in 2009?
Your answer should be compact. 0.59. What is the ratio of the Domestic credit (% of GDP) in Dominican Republic in 2007 to that in 2010?
Ensure brevity in your answer.  0.91. What is the ratio of the Domestic credit (% of GDP) of Papua New Guinea in 2007 to that in 2010?
Provide a short and direct response. 0.65. What is the ratio of the Domestic credit (% of GDP) in St. Kitts and Nevis in 2007 to that in 2010?
Keep it short and to the point. 0.89. What is the ratio of the Domestic credit (% of GDP) of Dominican Republic in 2007 to that in 2011?
Offer a very short reply. 0.91. What is the ratio of the Domestic credit (% of GDP) in Papua New Guinea in 2007 to that in 2011?
Offer a terse response. 0.74. What is the ratio of the Domestic credit (% of GDP) in St. Kitts and Nevis in 2007 to that in 2011?
Offer a very short reply. 0.97. What is the ratio of the Domestic credit (% of GDP) of Dominican Republic in 2007 to that in 2012?
Provide a short and direct response. 0.84. What is the ratio of the Domestic credit (% of GDP) of Papua New Guinea in 2007 to that in 2012?
Provide a short and direct response. 0.58. What is the ratio of the Domestic credit (% of GDP) in St. Kitts and Nevis in 2007 to that in 2012?
Keep it short and to the point. 1.03. What is the ratio of the Domestic credit (% of GDP) in Dominican Republic in 2008 to that in 2009?
Your answer should be compact. 0.94. What is the ratio of the Domestic credit (% of GDP) of Papua New Guinea in 2008 to that in 2009?
Your answer should be compact. 0.59. What is the ratio of the Domestic credit (% of GDP) of St. Kitts and Nevis in 2008 to that in 2009?
Offer a very short reply. 0.91. What is the ratio of the Domestic credit (% of GDP) of Dominican Republic in 2008 to that in 2010?
Provide a succinct answer. 0.95. What is the ratio of the Domestic credit (% of GDP) in Papua New Guinea in 2008 to that in 2010?
Offer a very short reply. 0.65. What is the ratio of the Domestic credit (% of GDP) of St. Kitts and Nevis in 2008 to that in 2010?
Offer a terse response. 0.84. What is the ratio of the Domestic credit (% of GDP) of Dominican Republic in 2008 to that in 2011?
Your response must be concise. 0.95. What is the ratio of the Domestic credit (% of GDP) in Papua New Guinea in 2008 to that in 2011?
Your answer should be very brief. 0.74. What is the ratio of the Domestic credit (% of GDP) in St. Kitts and Nevis in 2008 to that in 2011?
Provide a succinct answer. 0.91. What is the ratio of the Domestic credit (% of GDP) of Dominican Republic in 2008 to that in 2012?
Your response must be concise. 0.88. What is the ratio of the Domestic credit (% of GDP) in Papua New Guinea in 2008 to that in 2012?
Offer a very short reply. 0.58. What is the ratio of the Domestic credit (% of GDP) in St. Kitts and Nevis in 2008 to that in 2012?
Offer a very short reply. 0.97. What is the ratio of the Domestic credit (% of GDP) of Dominican Republic in 2009 to that in 2010?
Provide a succinct answer. 1.01. What is the ratio of the Domestic credit (% of GDP) of Papua New Guinea in 2009 to that in 2010?
Make the answer very short. 1.1. What is the ratio of the Domestic credit (% of GDP) in St. Kitts and Nevis in 2009 to that in 2010?
Offer a very short reply. 0.92. What is the ratio of the Domestic credit (% of GDP) in Papua New Guinea in 2009 to that in 2011?
Give a very brief answer. 1.25. What is the ratio of the Domestic credit (% of GDP) of Dominican Republic in 2009 to that in 2012?
Keep it short and to the point. 0.93. What is the ratio of the Domestic credit (% of GDP) in Papua New Guinea in 2009 to that in 2012?
Offer a terse response. 0.98. What is the ratio of the Domestic credit (% of GDP) in St. Kitts and Nevis in 2009 to that in 2012?
Keep it short and to the point. 1.07. What is the ratio of the Domestic credit (% of GDP) of Dominican Republic in 2010 to that in 2011?
Ensure brevity in your answer.  1. What is the ratio of the Domestic credit (% of GDP) of Papua New Guinea in 2010 to that in 2011?
Provide a short and direct response. 1.14. What is the ratio of the Domestic credit (% of GDP) of St. Kitts and Nevis in 2010 to that in 2011?
Your answer should be compact. 1.08. What is the ratio of the Domestic credit (% of GDP) of Dominican Republic in 2010 to that in 2012?
Offer a terse response. 0.92. What is the ratio of the Domestic credit (% of GDP) of Papua New Guinea in 2010 to that in 2012?
Give a very brief answer. 0.89. What is the ratio of the Domestic credit (% of GDP) in St. Kitts and Nevis in 2010 to that in 2012?
Ensure brevity in your answer.  1.16. What is the ratio of the Domestic credit (% of GDP) in Dominican Republic in 2011 to that in 2012?
Provide a succinct answer. 0.92. What is the ratio of the Domestic credit (% of GDP) in Papua New Guinea in 2011 to that in 2012?
Offer a terse response. 0.78. What is the ratio of the Domestic credit (% of GDP) in St. Kitts and Nevis in 2011 to that in 2012?
Your response must be concise. 1.07. What is the difference between the highest and the second highest Domestic credit (% of GDP) in Dominican Republic?
Make the answer very short. 2.97. What is the difference between the highest and the second highest Domestic credit (% of GDP) in Papua New Guinea?
Your answer should be very brief. 0.92. What is the difference between the highest and the second highest Domestic credit (% of GDP) of St. Kitts and Nevis?
Provide a succinct answer. 9.72. What is the difference between the highest and the lowest Domestic credit (% of GDP) in Dominican Republic?
Make the answer very short. 13.42. What is the difference between the highest and the lowest Domestic credit (% of GDP) in Papua New Guinea?
Your answer should be compact. 16.77. What is the difference between the highest and the lowest Domestic credit (% of GDP) of St. Kitts and Nevis?
Provide a short and direct response. 20.21. 